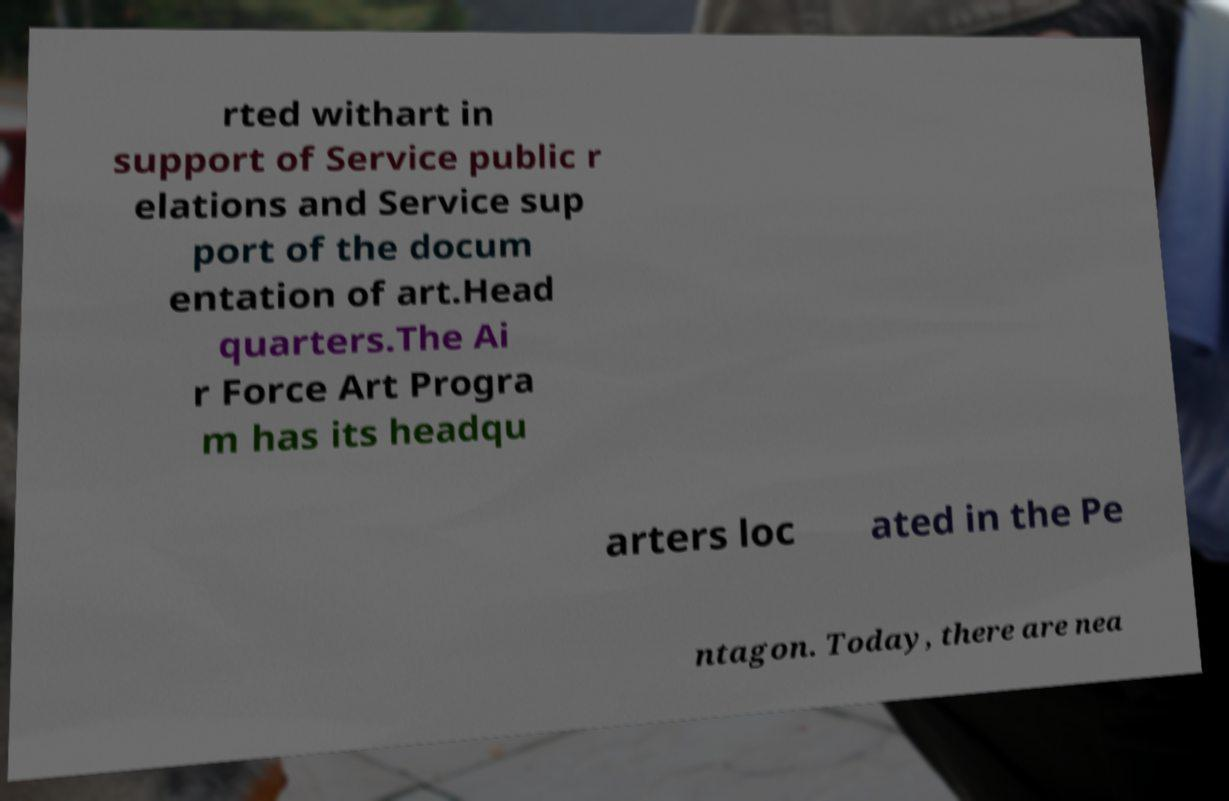For documentation purposes, I need the text within this image transcribed. Could you provide that? rted withart in support of Service public r elations and Service sup port of the docum entation of art.Head quarters.The Ai r Force Art Progra m has its headqu arters loc ated in the Pe ntagon. Today, there are nea 